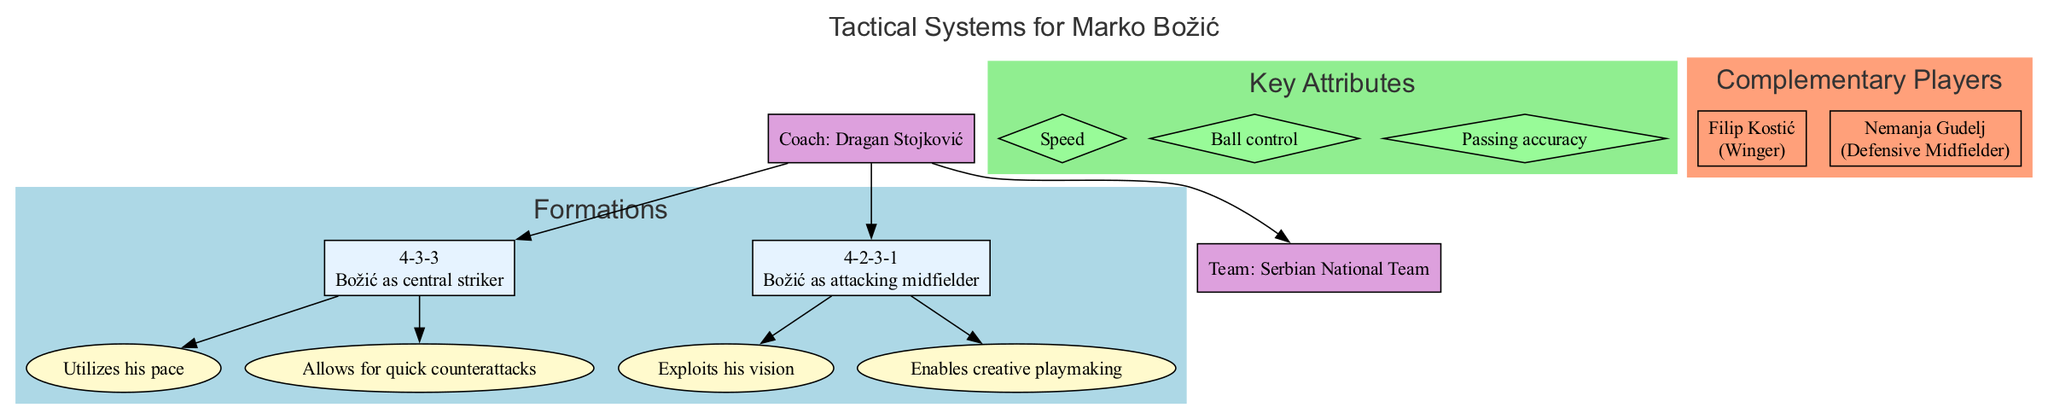What are the two tactical formations discussed in the diagram? The diagram explicitly lists two formations: "4-3-3" and "4-2-3-1." These are clearly labeled under the formations section.
Answer: 4-3-3 and 4-2-3-1 What position does Marko Božić play in the 4-3-3 formation? The diagram specifies that Božić plays as the central striker in the 4-3-3 formation, which is mentioned in its description.
Answer: Central striker What is one key attribute of Marko Božić? The diagram lists speed, ball control, and passing accuracy as key attributes, indicating he possesses at least one of these traits.
Answer: Speed Who are the complementary players listed in the diagram? The diagram shows two complementary players: Filip Kostić and Nemanja Gudelj, along with their respective positions.
Answer: Filip Kostić and Nemanja Gudelj How many strengths are associated with the 4-2-3-1 formation? The diagram indicates that the 4-2-3-1 formation has two strengths listed, which are drawn from the strengths section specific to that formation.
Answer: 2 What color represents the formations section in the diagram? The diagram designates a light blue color for the formations section, as specified in the style attributes of the diagram.
Answer: Light blue What coaching role is indicated in the diagram? The diagram clearly states the role of "Coach" associated with Dragan Stojković, making it evident.
Answer: Coach Which formation utilizes quick counterattacks as a strength? The diagram specifically states that the 4-3-3 formation has a strength of allowing for quick counterattacks, as shown in the strengths section.
Answer: 4-3-3 In what position is Nemanja Gudelj categorized in the complementary players section? The diagram specifies Nemanja Gudelj as a Defensive Midfielder, which is included in his description within the complementary players section.
Answer: Defensive Midfielder 